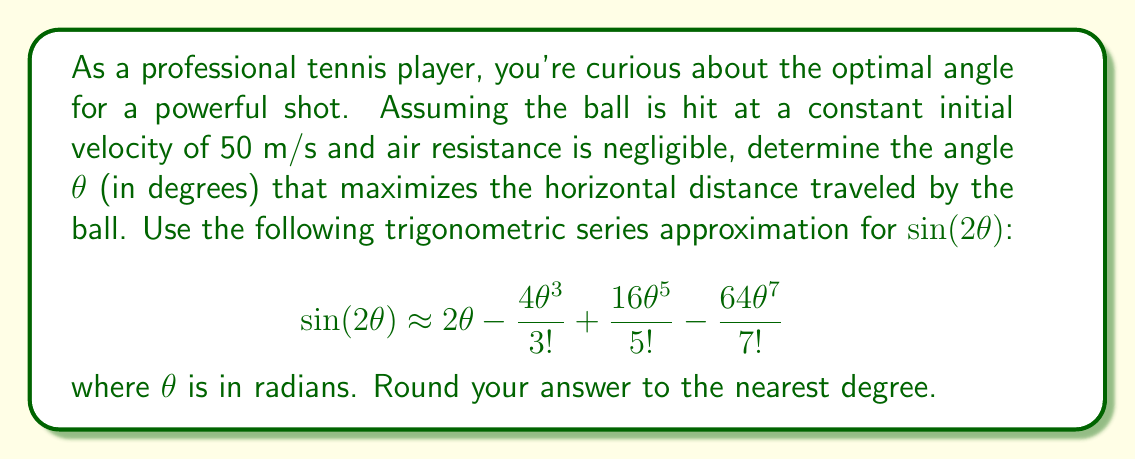What is the answer to this math problem? Let's approach this step-by-step:

1) The horizontal distance traveled by a projectile is given by the formula:

   $$R = \frac{v^2}{g} \sin(2\theta)$$

   where v is the initial velocity, g is the acceleration due to gravity (9.8 m/s²), and θ is the launch angle.

2) To maximize R, we need to maximize sin(2θ). In general, this occurs when 2θ = 90°, or θ = 45°. However, we'll use the given series approximation to find a more precise answer.

3) Let's substitute the series approximation for sin(2θ):

   $$R = \frac{v^2}{g} (2\theta - \frac{4\theta^3}{3!} + \frac{16\theta^5}{5!} - \frac{64\theta^7}{7!})$$

4) To find the maximum, we need to differentiate R with respect to θ and set it to zero:

   $$\frac{dR}{d\theta} = \frac{v^2}{g} (2 - 4\theta^2 + \frac{16\theta^4}{4!} - \frac{64\theta^6}{6!}) = 0$$

5) Solving this equation exactly is complex, so let's use an iterative method starting with our initial guess of 45° (π/4 radians):

   θ₀ = π/4 ≈ 0.7854 radians

6) Plugging this into our derivative equation:

   $$2 - 4(0.7854)^2 + \frac{16(0.7854)^4}{24} - \frac{64(0.7854)^6}{720} \approx -0.0127$$

7) This is close to zero, but we can do better. Let's try a slightly smaller angle:

   θ₁ = 0.78 radians

8) Plugging this in:

   $$2 - 4(0.78)^2 + \frac{16(0.78)^4}{24} - \frac{64(0.78)^6}{720} \approx 0.0004$$

9) This is very close to zero, so we'll stop here. 0.78 radians is approximately 44.7°.

10) Rounding to the nearest degree, we get 45°.
Answer: 45° 